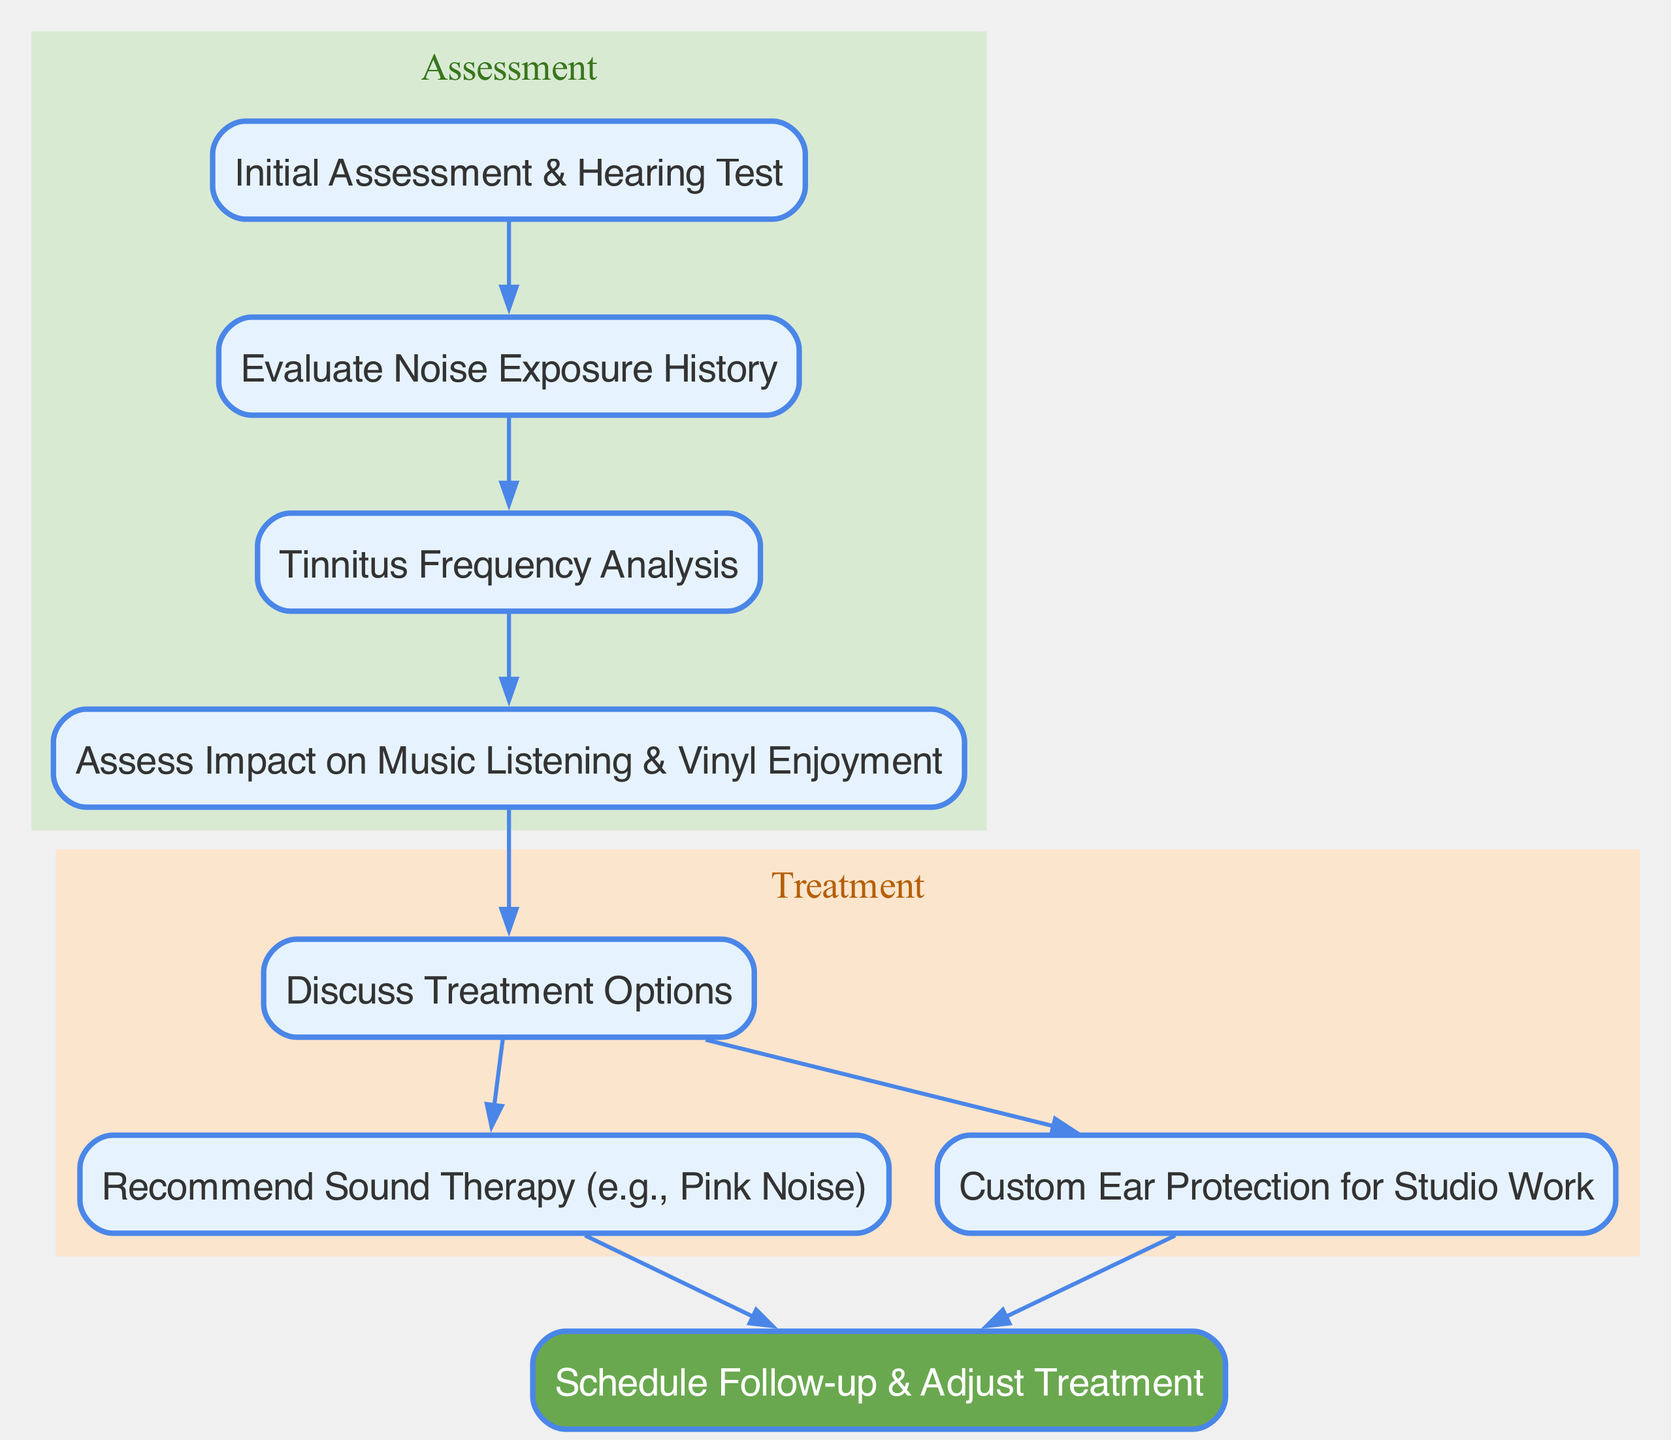What is the first step in the clinical pathway? The first step is represented by the "Initial Assessment & Hearing Test" node, which initiates the clinical pathway for managing tinnitus.
Answer: Initial Assessment & Hearing Test How many nodes are there in the diagram? By counting all the unique "nodes" provided in the data, we find a total of eight nodes.
Answer: 8 What is the last action taken in the clinical pathway? The last action is represented by the "Schedule Follow-up & Adjust Treatment" node, indicating the end of the treatment process.
Answer: Schedule Follow-up & Adjust Treatment Which assessment is directly related to evaluating music listening impacts? The "Assess Impact on Music Listening & Vinyl Enjoyment" node is directly related to this assessment as it focuses specifically on music listening.
Answer: Assess Impact on Music Listening & Vinyl Enjoyment What treatments are discussed after assessing impact? The treatments discussed after the "Assess Impact on Music Listening & Vinyl Enjoyment" are represented by the "Discuss Treatment Options" node, which leads to options like sound therapy and ear protection.
Answer: Discuss Treatment Options How is sound therapy connected to follow-up? The connection is made by an edge that leads from "Recommend Sound Therapy (e.g., Pink Noise)" directly to "Schedule Follow-up & Adjust Treatment," indicating that after sound therapy, a follow-up is required.
Answer: Recommend Sound Therapy (e.g., Pink Noise) What type of node is "Custom Ear Protection for Studio Work"? "Custom Ear Protection for Studio Work" is a treatment node in the therapy cluster that provides options for managing tinnitus while working in noisy environments.
Answer: Treatment node Which node assesses noise exposure history? "Evaluate Noise Exposure History" is the specific node that is focused on the assessment of the patient's noise exposure history.
Answer: Evaluate Noise Exposure History What is the relationship between evaluating noise exposure and frequency analysis? The relationship is direct, as the edge connects "Evaluate Noise Exposure History" to "Tinnitus Frequency Analysis," indicating that assessing noise exposure leads to frequency analysis.
Answer: Direct relationship 